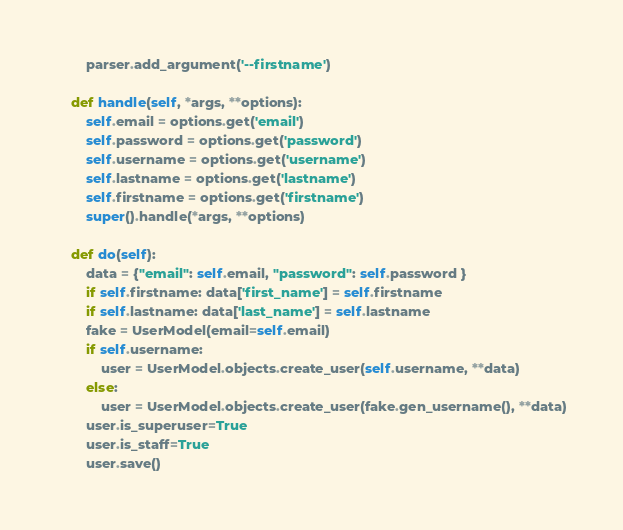<code> <loc_0><loc_0><loc_500><loc_500><_Python_>        parser.add_argument('--firstname')

    def handle(self, *args, **options):
        self.email = options.get('email')
        self.password = options.get('password')
        self.username = options.get('username')
        self.lastname = options.get('lastname')
        self.firstname = options.get('firstname')
        super().handle(*args, **options)

    def do(self):
        data = {"email": self.email, "password": self.password }
        if self.firstname: data['first_name'] = self.firstname
        if self.lastname: data['last_name'] = self.lastname
        fake = UserModel(email=self.email)
        if self.username: 
            user = UserModel.objects.create_user(self.username, **data)
        else:
            user = UserModel.objects.create_user(fake.gen_username(), **data)
        user.is_superuser=True
        user.is_staff=True
        user.save()
</code> 